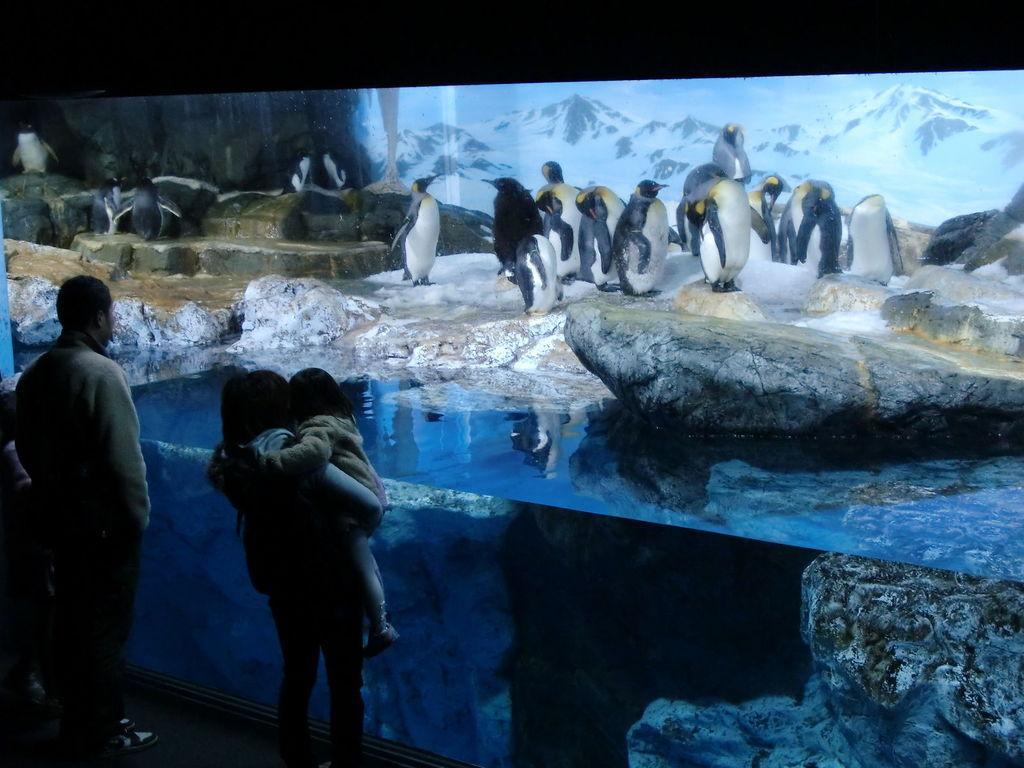Describe this image in one or two sentences. In this image we can see penguins on the ice, at back here are the mountains, here is the rock, here is the water, here are the persons standing. 